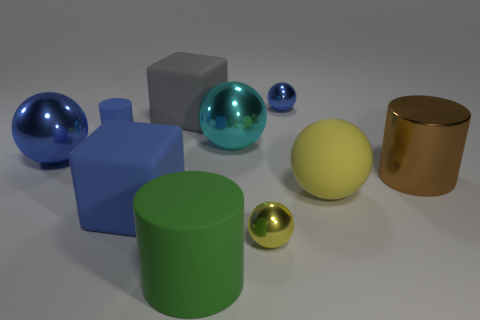There is a blue thing that is in front of the rubber sphere; is it the same shape as the big gray thing?
Your answer should be compact. Yes. Is there a brown metal cylinder that has the same size as the green rubber thing?
Ensure brevity in your answer.  Yes. Is the shape of the tiny matte object the same as the yellow rubber object to the right of the big rubber cylinder?
Give a very brief answer. No. What is the shape of the small object that is the same color as the tiny cylinder?
Your answer should be very brief. Sphere. Is the number of brown metal things that are behind the tiny blue metal sphere less than the number of gray blocks?
Keep it short and to the point. Yes. Is the big green object the same shape as the large gray matte thing?
Offer a very short reply. No. What size is the gray cube that is made of the same material as the big yellow sphere?
Offer a terse response. Large. Is the number of small red shiny things less than the number of blue matte blocks?
Provide a succinct answer. Yes. What number of large things are either blue metallic things or green metallic cubes?
Your response must be concise. 1. What number of things are in front of the shiny cylinder and left of the gray thing?
Provide a succinct answer. 1. 